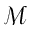Convert formula to latex. <formula><loc_0><loc_0><loc_500><loc_500>\mathcal { M }</formula> 